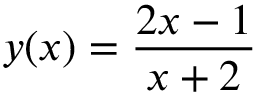<formula> <loc_0><loc_0><loc_500><loc_500>y ( x ) = { \frac { 2 x - 1 } { x + 2 } }</formula> 